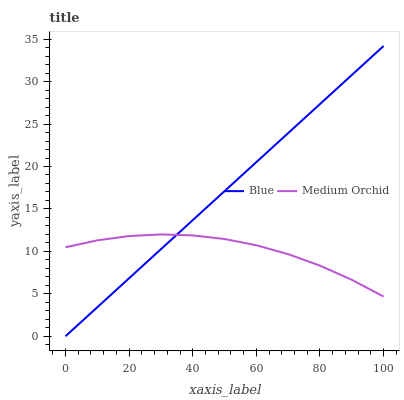Does Medium Orchid have the minimum area under the curve?
Answer yes or no. Yes. Does Blue have the maximum area under the curve?
Answer yes or no. Yes. Does Medium Orchid have the maximum area under the curve?
Answer yes or no. No. Is Blue the smoothest?
Answer yes or no. Yes. Is Medium Orchid the roughest?
Answer yes or no. Yes. Is Medium Orchid the smoothest?
Answer yes or no. No. Does Blue have the lowest value?
Answer yes or no. Yes. Does Medium Orchid have the lowest value?
Answer yes or no. No. Does Blue have the highest value?
Answer yes or no. Yes. Does Medium Orchid have the highest value?
Answer yes or no. No. Does Medium Orchid intersect Blue?
Answer yes or no. Yes. Is Medium Orchid less than Blue?
Answer yes or no. No. Is Medium Orchid greater than Blue?
Answer yes or no. No. 